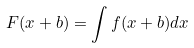<formula> <loc_0><loc_0><loc_500><loc_500>F ( x + b ) = \int f ( x + b ) d x</formula> 